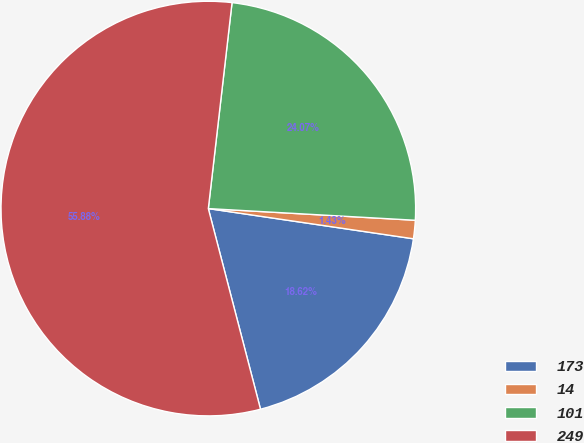Convert chart. <chart><loc_0><loc_0><loc_500><loc_500><pie_chart><fcel>173<fcel>14<fcel>101<fcel>249<nl><fcel>18.62%<fcel>1.43%<fcel>24.07%<fcel>55.87%<nl></chart> 